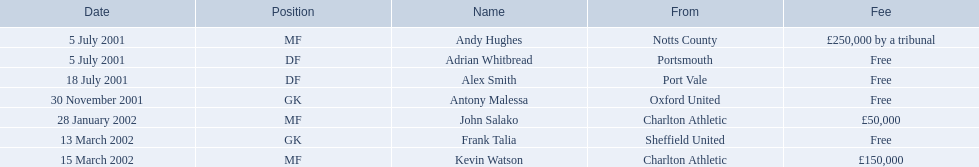Who were all the players? Andy Hughes, Adrian Whitbread, Alex Smith, Antony Malessa, John Salako, Frank Talia, Kevin Watson. What were the transfer fees of these players? £250,000 by a tribunal, Free, Free, Free, £50,000, Free, £150,000. Of these, which belong to andy hughes and john salako? £250,000 by a tribunal, £50,000. Of these, which is larger? £250,000 by a tribunal. Which player commanded this fee? Andy Hughes. 